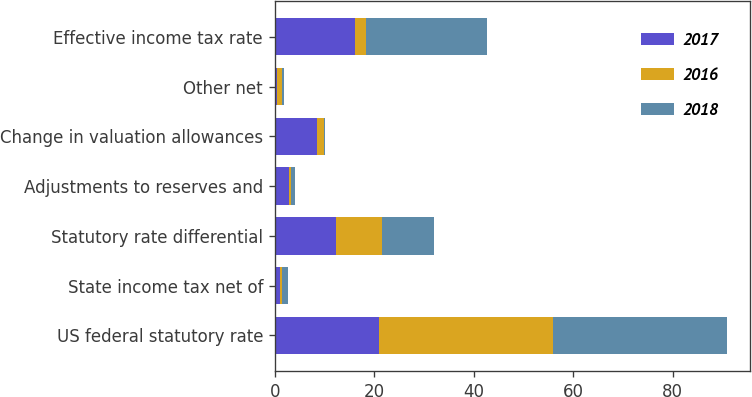Convert chart to OTSL. <chart><loc_0><loc_0><loc_500><loc_500><stacked_bar_chart><ecel><fcel>US federal statutory rate<fcel>State income tax net of<fcel>Statutory rate differential<fcel>Adjustments to reserves and<fcel>Change in valuation allowances<fcel>Other net<fcel>Effective income tax rate<nl><fcel>2017<fcel>21<fcel>1<fcel>12.3<fcel>2.8<fcel>8.5<fcel>0.4<fcel>16.2<nl><fcel>2016<fcel>35<fcel>0.5<fcel>9.3<fcel>0.5<fcel>1.5<fcel>1.1<fcel>2.15<nl><fcel>2018<fcel>35<fcel>1.1<fcel>10.5<fcel>0.8<fcel>0.2<fcel>0.3<fcel>24.3<nl></chart> 